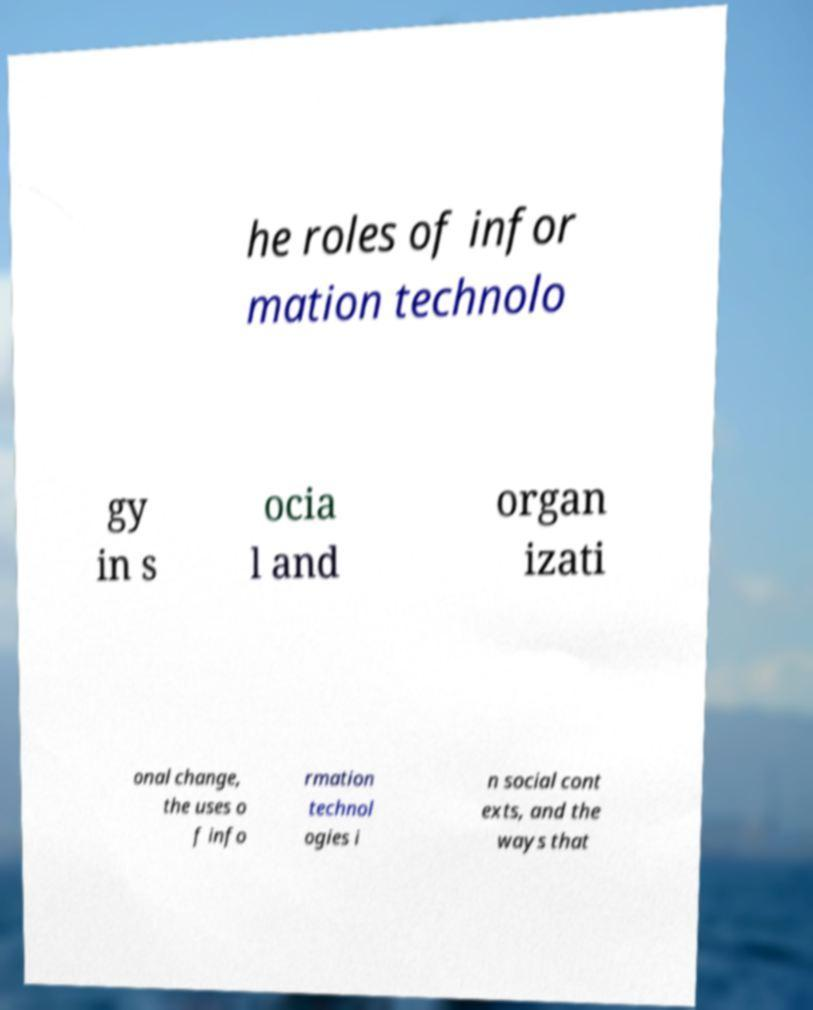For documentation purposes, I need the text within this image transcribed. Could you provide that? he roles of infor mation technolo gy in s ocia l and organ izati onal change, the uses o f info rmation technol ogies i n social cont exts, and the ways that 